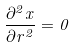Convert formula to latex. <formula><loc_0><loc_0><loc_500><loc_500>\frac { \partial ^ { 2 } x } { \partial r ^ { 2 } } = 0</formula> 